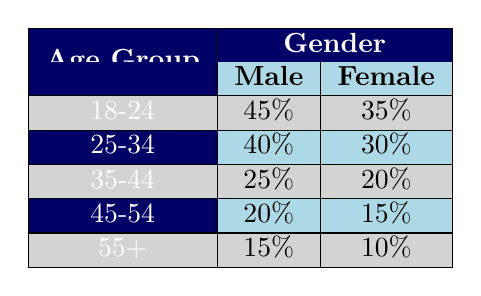What percentage of the audience for sci-fi movies aged 45-54 is female? According to the table, for the age group 45-54, the percentage for females is 15%. This is directly referenced from the corresponding row in the table.
Answer: 15% Which age group has the highest percentage of male viewers? The table indicates that the 18-24 age group has the highest percentage of male viewers at 45%. This information can be found by comparing all the percentages listed for male viewers across different age groups.
Answer: 18-24 Is the percentage of female viewers in the 25-34 age group greater than that of female viewers in the 35-44 age group? For the 25-34 age group, the percentage of female viewers is 30%, and for the 35-44 age group, it is 20%. Since 30% is greater than 20%, the statement is true.
Answer: Yes What is the total percentage of male viewers across all age groups? To find the total percentage of male viewers, add the percentages from each male row: 45% (18-24) + 40% (25-34) + 25% (35-44) + 20% (45-54) + 15% (55+) = 145%. Therefore, the total percentage of male viewers is 145%.
Answer: 145% Are there more female viewers aged 18-24 than there are male viewers aged 55 and older? The percentage of female viewers aged 18-24 is 35%, while the percentage of male viewers aged 55 and older is 15%. Since 35% is greater than 15%, the statement is true.
Answer: Yes What is the difference in percentage between the male viewers of the age groups 25-34 and 35-44? The percentage for males aged 25-34 is 40%, and for males aged 35-44 it is 25%. The difference is calculated as 40% - 25% = 15%.
Answer: 15% What is the average percentage of female viewers across all age groups? To calculate the average, first sum the percentages of female viewers: 35% (18-24) + 30% (25-34) + 20% (35-44) + 15% (45-54) + 10% (55+) = 110%. There are 5 age groups, so the average is 110% / 5 = 22%.
Answer: 22% Which age group has the lowest percentage of male viewers? The table indicates that the 55+ age group has the lowest percentage of male viewers at 15%. This can be determined by reviewing all the male percentages in the table.
Answer: 55+ Is it true that there are no female viewers in the age group 45-54? According to the table, there are female viewers in the 45-54 age group, with a percentage of 15%. This information is easily found by looking at the corresponding row for that age group. Thus, the statement is false.
Answer: No 